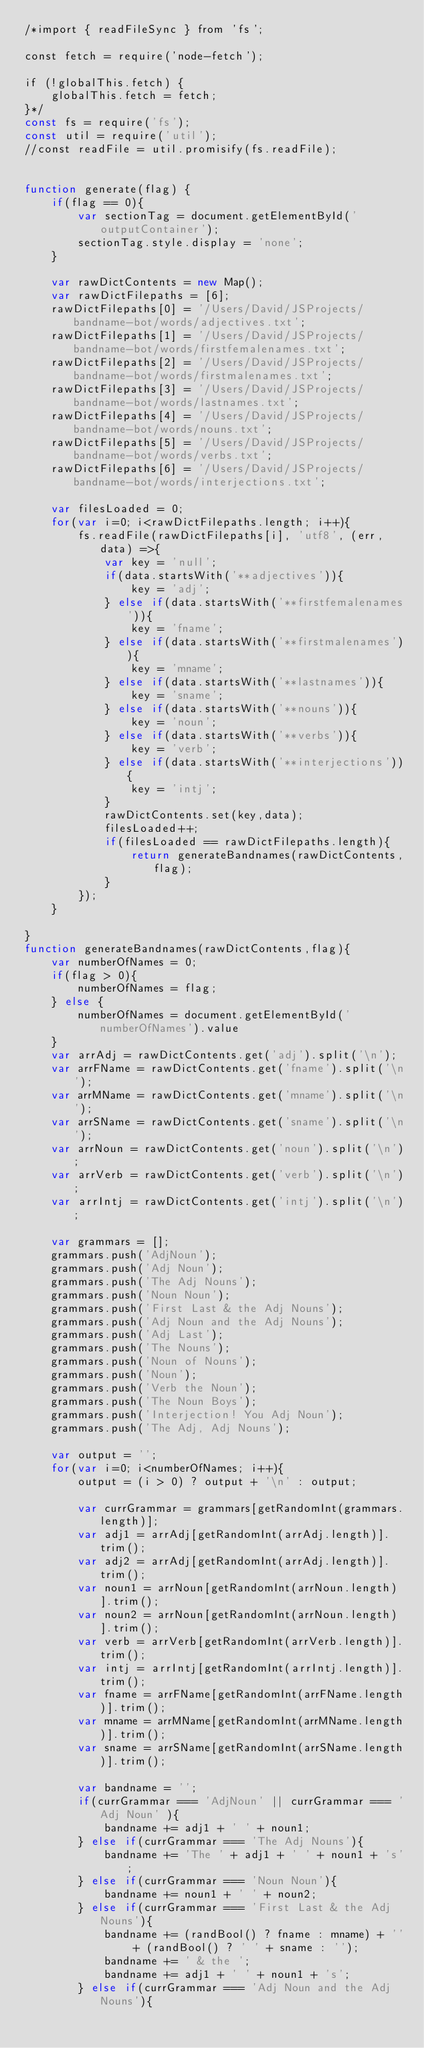Convert code to text. <code><loc_0><loc_0><loc_500><loc_500><_JavaScript_>/*import { readFileSync } from 'fs';

const fetch = require('node-fetch');

if (!globalThis.fetch) {
    globalThis.fetch = fetch;
}*/
const fs = require('fs');
const util = require('util');
//const readFile = util.promisify(fs.readFile);


function generate(flag) {
    if(flag == 0){
        var sectionTag = document.getElementById('outputContainer');
        sectionTag.style.display = 'none';
    }

    var rawDictContents = new Map();
    var rawDictFilepaths = [6];
    rawDictFilepaths[0] = '/Users/David/JSProjects/bandname-bot/words/adjectives.txt';
    rawDictFilepaths[1] = '/Users/David/JSProjects/bandname-bot/words/firstfemalenames.txt';
    rawDictFilepaths[2] = '/Users/David/JSProjects/bandname-bot/words/firstmalenames.txt';
    rawDictFilepaths[3] = '/Users/David/JSProjects/bandname-bot/words/lastnames.txt';
    rawDictFilepaths[4] = '/Users/David/JSProjects/bandname-bot/words/nouns.txt';
    rawDictFilepaths[5] = '/Users/David/JSProjects/bandname-bot/words/verbs.txt';
    rawDictFilepaths[6] = '/Users/David/JSProjects/bandname-bot/words/interjections.txt';

    var filesLoaded = 0;
    for(var i=0; i<rawDictFilepaths.length; i++){
        fs.readFile(rawDictFilepaths[i], 'utf8', (err, data) =>{
            var key = 'null';
            if(data.startsWith('**adjectives')){
                key = 'adj';
            } else if(data.startsWith('**firstfemalenames')){
                key = 'fname';
            } else if(data.startsWith('**firstmalenames')){
                key = 'mname';
            } else if(data.startsWith('**lastnames')){
                key = 'sname';
            } else if(data.startsWith('**nouns')){
                key = 'noun';
            } else if(data.startsWith('**verbs')){
                key = 'verb';
            } else if(data.startsWith('**interjections')){
                key = 'intj';
            }
            rawDictContents.set(key,data);
            filesLoaded++;
            if(filesLoaded == rawDictFilepaths.length){
                return generateBandnames(rawDictContents,flag);
            }
        });
    }

}
function generateBandnames(rawDictContents,flag){
    var numberOfNames = 0;
    if(flag > 0){
        numberOfNames = flag;
    } else {
        numberOfNames = document.getElementById('numberOfNames').value
    }
    var arrAdj = rawDictContents.get('adj').split('\n');
    var arrFName = rawDictContents.get('fname').split('\n');
    var arrMName = rawDictContents.get('mname').split('\n');
    var arrSName = rawDictContents.get('sname').split('\n');
    var arrNoun = rawDictContents.get('noun').split('\n');
    var arrVerb = rawDictContents.get('verb').split('\n');
    var arrIntj = rawDictContents.get('intj').split('\n');

    var grammars = [];
    grammars.push('AdjNoun');
    grammars.push('Adj Noun');
    grammars.push('The Adj Nouns');
    grammars.push('Noun Noun');
    grammars.push('First Last & the Adj Nouns');
    grammars.push('Adj Noun and the Adj Nouns');
    grammars.push('Adj Last');
    grammars.push('The Nouns');
    grammars.push('Noun of Nouns');
    grammars.push('Noun');
    grammars.push('Verb the Noun');
    grammars.push('The Noun Boys');
    grammars.push('Interjection! You Adj Noun');
    grammars.push('The Adj, Adj Nouns');

    var output = '';
    for(var i=0; i<numberOfNames; i++){
        output = (i > 0) ? output + '\n' : output;

        var currGrammar = grammars[getRandomInt(grammars.length)];
        var adj1 = arrAdj[getRandomInt(arrAdj.length)].trim();
        var adj2 = arrAdj[getRandomInt(arrAdj.length)].trim();
        var noun1 = arrNoun[getRandomInt(arrNoun.length)].trim();
        var noun2 = arrNoun[getRandomInt(arrNoun.length)].trim();
        var verb = arrVerb[getRandomInt(arrVerb.length)].trim();
        var intj = arrIntj[getRandomInt(arrIntj.length)].trim();
        var fname = arrFName[getRandomInt(arrFName.length)].trim();
        var mname = arrMName[getRandomInt(arrMName.length)].trim();
        var sname = arrSName[getRandomInt(arrSName.length)].trim();

        var bandname = '';
        if(currGrammar === 'AdjNoun' || currGrammar === 'Adj Noun' ){
            bandname += adj1 + ' ' + noun1;
        } else if(currGrammar === 'The Adj Nouns'){
            bandname += 'The ' + adj1 + ' ' + noun1 + 's';
        } else if(currGrammar === 'Noun Noun'){
            bandname += noun1 + ' ' + noun2;
        } else if(currGrammar === 'First Last & the Adj Nouns'){
            bandname += (randBool() ? fname : mname) + '' + (randBool() ? ' ' + sname : '');
            bandname += ' & the ';
            bandname += adj1 + ' ' + noun1 + 's';
        } else if(currGrammar === 'Adj Noun and the Adj Nouns'){</code> 